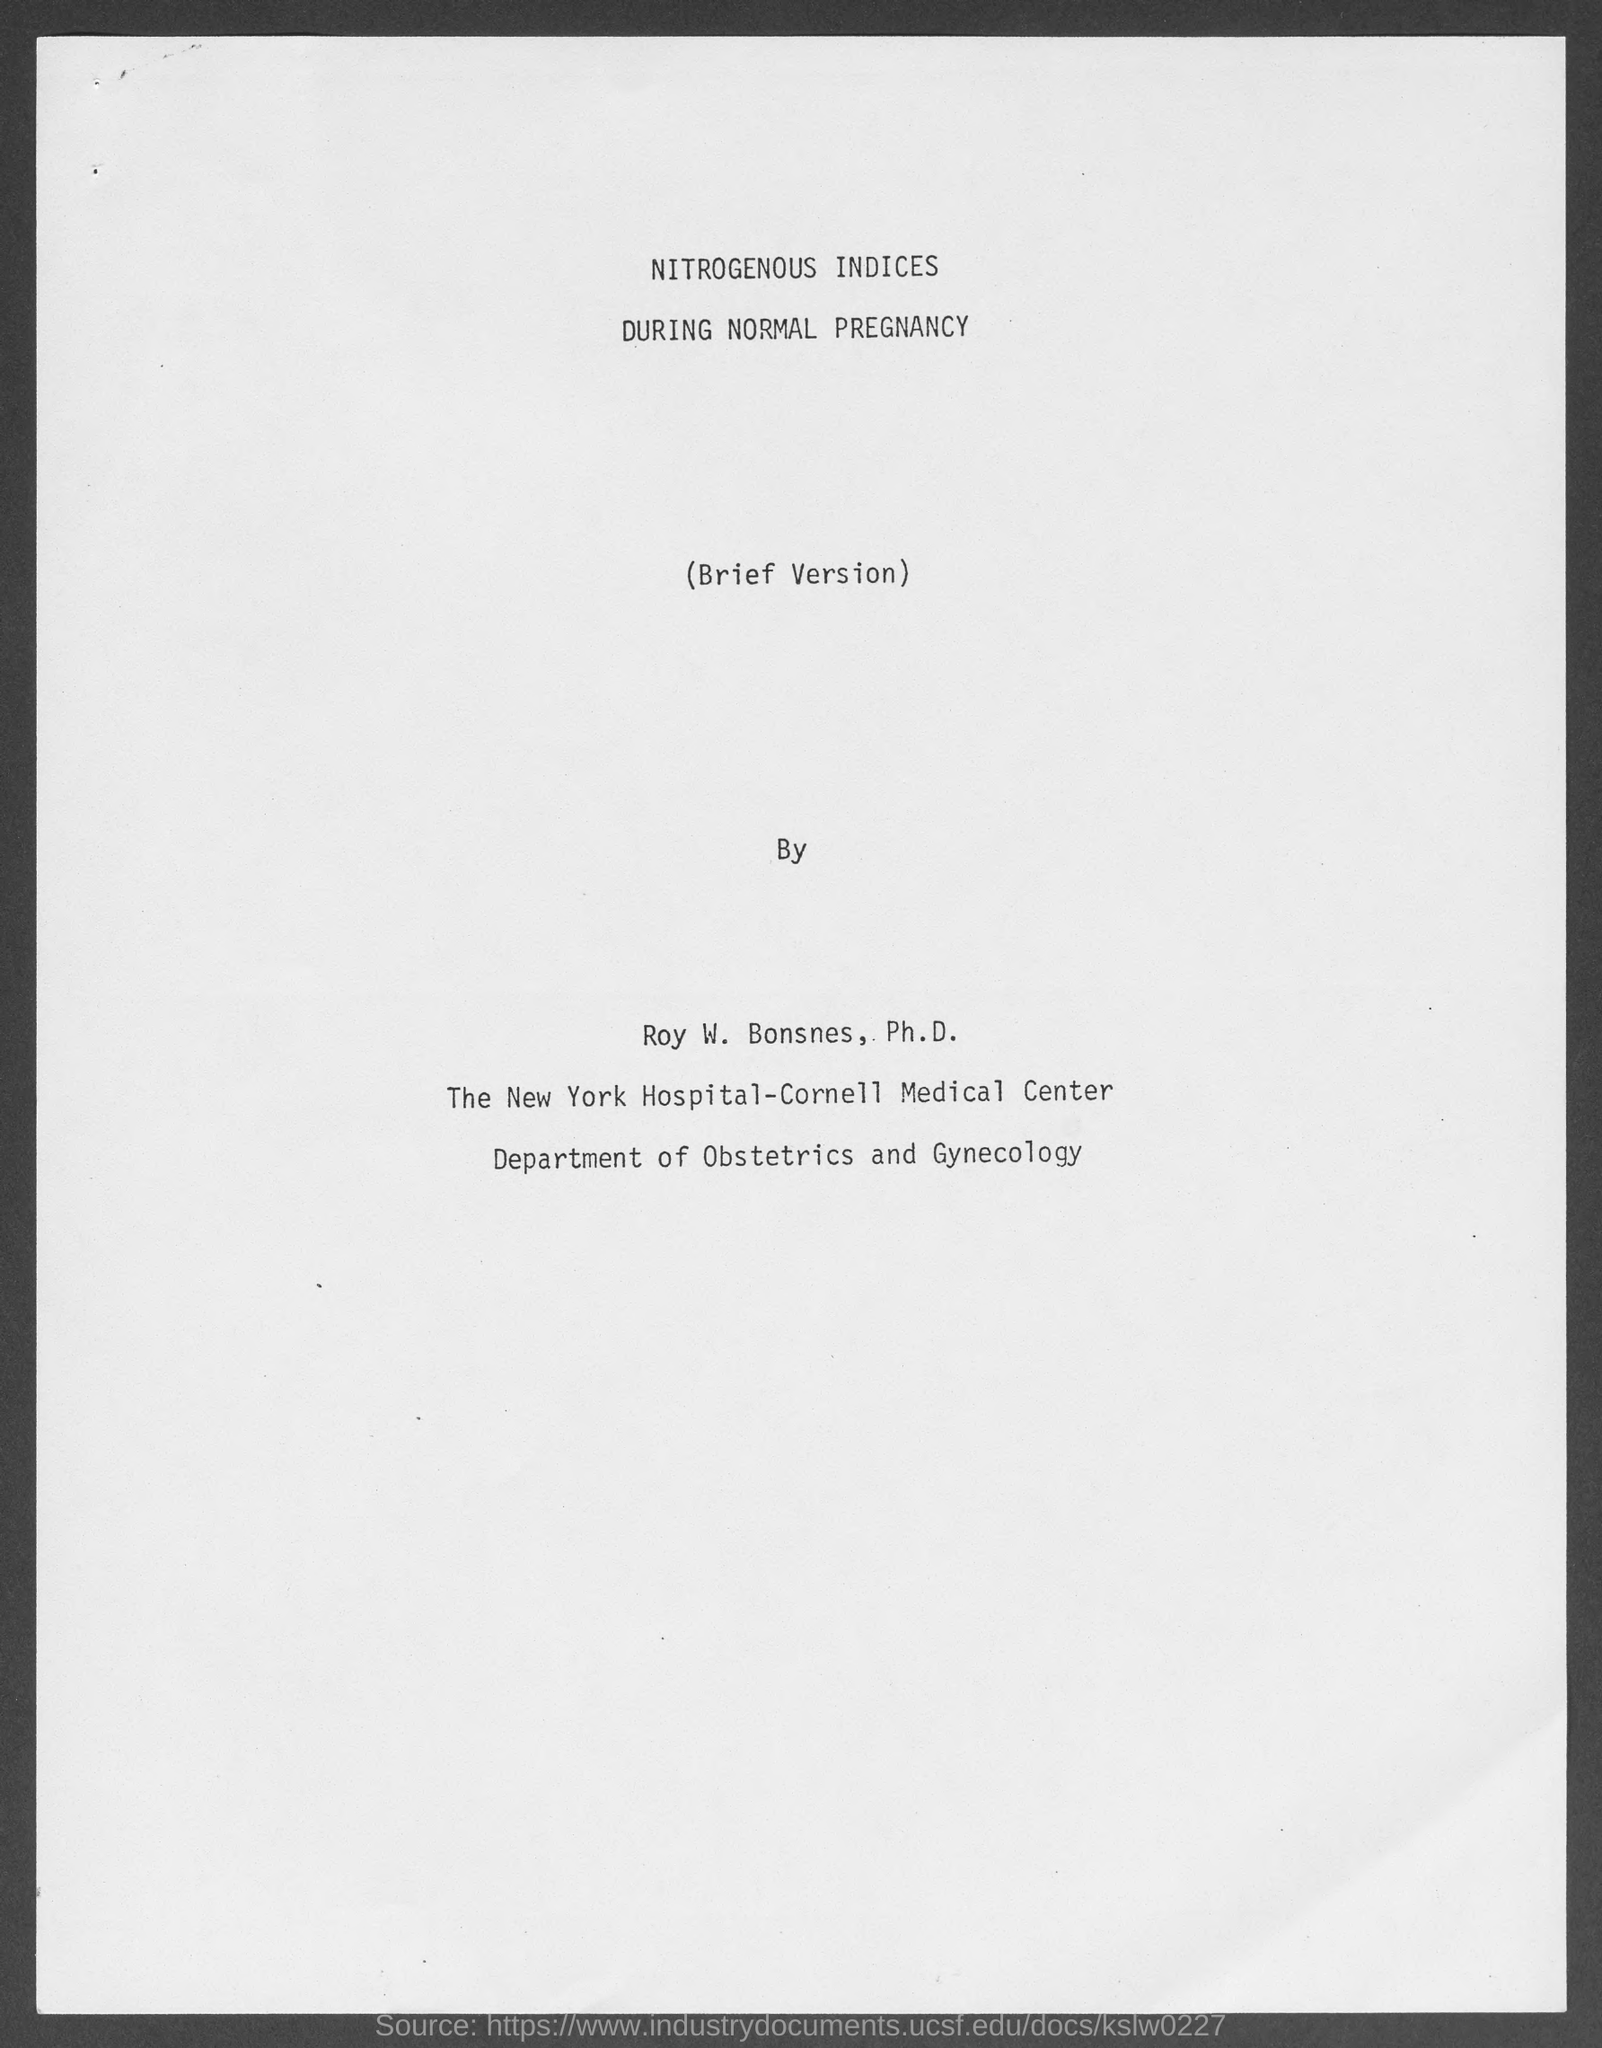To which department does roy w. bonses, ph.d. belong?
Your response must be concise. Department of obstetrics and gynecology. 